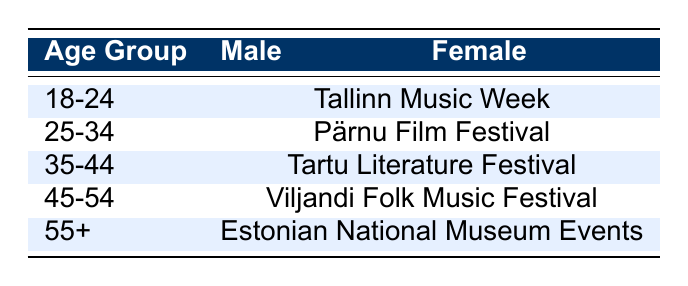What cultural event do both 18-24-year-old males and females prefer? Both 18-24-year-old males and females show a preference for Tallinn Music Week, as it is listed under their age group with no distinction between genders.
Answer: Tallinn Music Week Which event is preferred by the 25-34 age group? The preference for the 25-34 age group, regardless of gender, is for the Pärnu Film Festival, as indicated by the combined entry under that age category.
Answer: Pärnu Film Festival Is there any difference in event preference for 35-44-year-olds based on gender? No, both male and female participants in the 35-44 age group prefer the same event, which is the Tartu Literature Festival, thus indicating no gender-based difference for this age group.
Answer: No Which event is favored by the older age group (55+)? The 55+ age group, both males and females, favor the Estonian National Museum Events, as denoted by the entry in their respective row.
Answer: Estonian National Museum Events What is the total number of cultural events preferred across all age groups included in the table? There are five distinct cultural events mentioned in the table: Tallinn Music Week, Pärnu Film Festival, Tartu Literature Festival, Viljandi Folk Music Festival, and Estonian National Museum Events, totaling to five.
Answer: 5 Do both genders in the 45-54 age group have the same event preference? Yes, both genders in the 45-54 age group show a preference for the Viljandi Folk Music Festival, as reflected in the table for that age group.
Answer: Yes What is the pattern of event preference from the youngest to the oldest age group? The pattern shows a consistent structure where each age group has a particular event preference, moving from Tallinn Music Week for the youngest group, up to the Estonian National Museum Events for the oldest, maintaining separate events for each age group without any overlaps.
Answer: Consistent structure Is it correct that all age groups show preferences for different events? Yes, each age group from 18-24 to 55+ has a unique event preference listed in the table, indicating that there are no shared preferences across the age groups.
Answer: Yes 